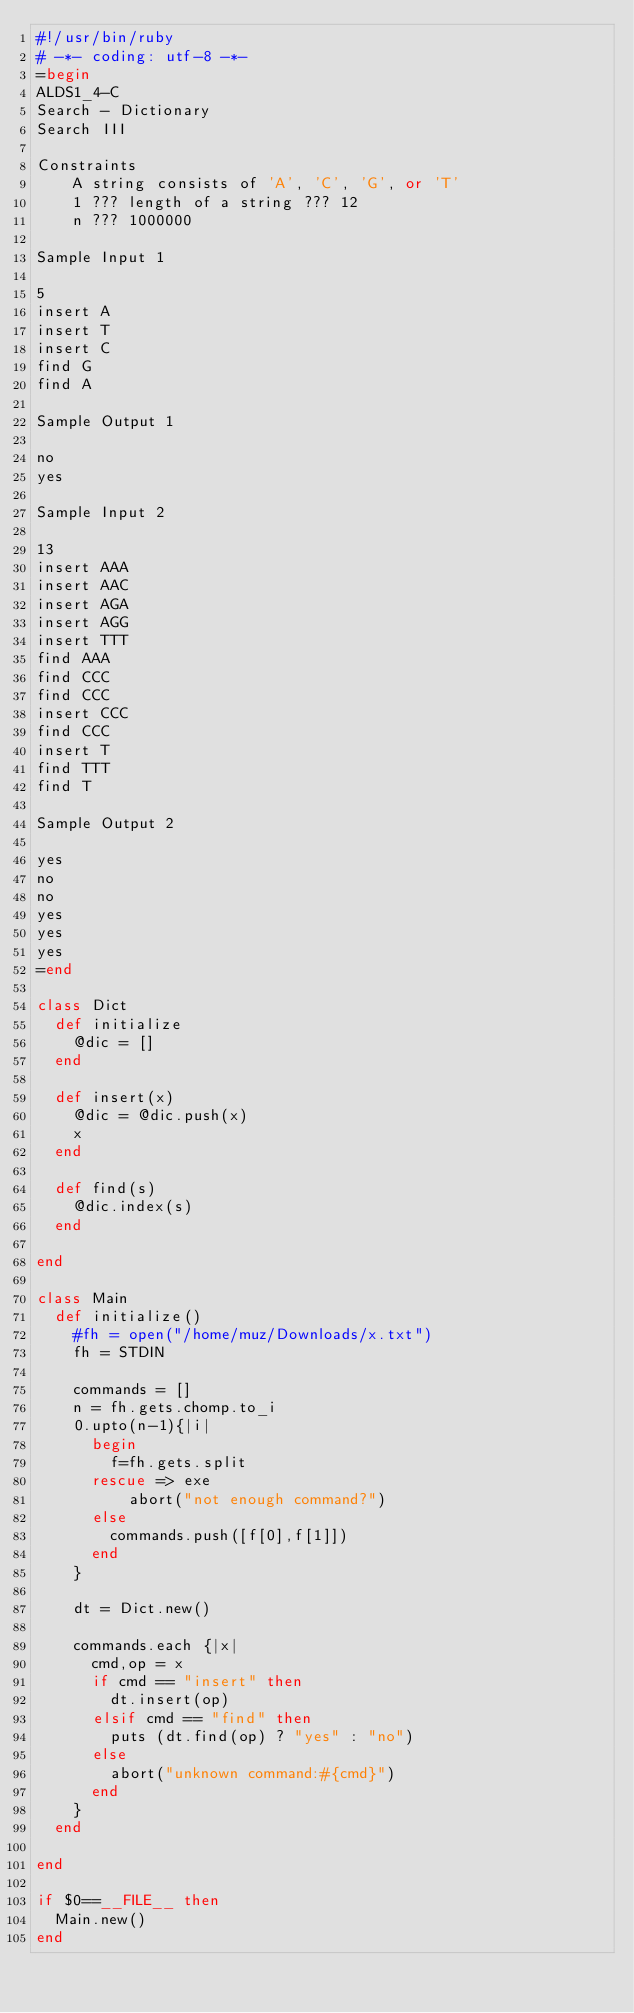Convert code to text. <code><loc_0><loc_0><loc_500><loc_500><_Ruby_>#!/usr/bin/ruby
# -*- coding: utf-8 -*-
=begin
ALDS1_4-C
Search - Dictionary
Search III

Constraints
    A string consists of 'A', 'C', 'G', or 'T'
    1 ??? length of a string ??? 12
    n ??? 1000000

Sample Input 1

5
insert A
insert T
insert C
find G
find A

Sample Output 1

no
yes

Sample Input 2

13
insert AAA
insert AAC
insert AGA
insert AGG
insert TTT
find AAA
find CCC
find CCC
insert CCC
find CCC
insert T
find TTT
find T

Sample Output 2

yes
no
no
yes
yes
yes
=end

class Dict
  def initialize
    @dic = []
  end

  def insert(x)
    @dic = @dic.push(x)
    x
  end

  def find(s)
    @dic.index(s)
  end

end

class Main
  def initialize()
    #fh = open("/home/muz/Downloads/x.txt")
    fh = STDIN

    commands = []
    n = fh.gets.chomp.to_i
    0.upto(n-1){|i|
      begin
        f=fh.gets.split
      rescue => exe
          abort("not enough command?")
      else
        commands.push([f[0],f[1]])
      end
    }

    dt = Dict.new()

    commands.each {|x|
      cmd,op = x
      if cmd == "insert" then
        dt.insert(op)
      elsif cmd == "find" then
        puts (dt.find(op) ? "yes" : "no")
      else
        abort("unknown command:#{cmd}")
      end
    }
  end

end

if $0==__FILE__ then
  Main.new()
end</code> 